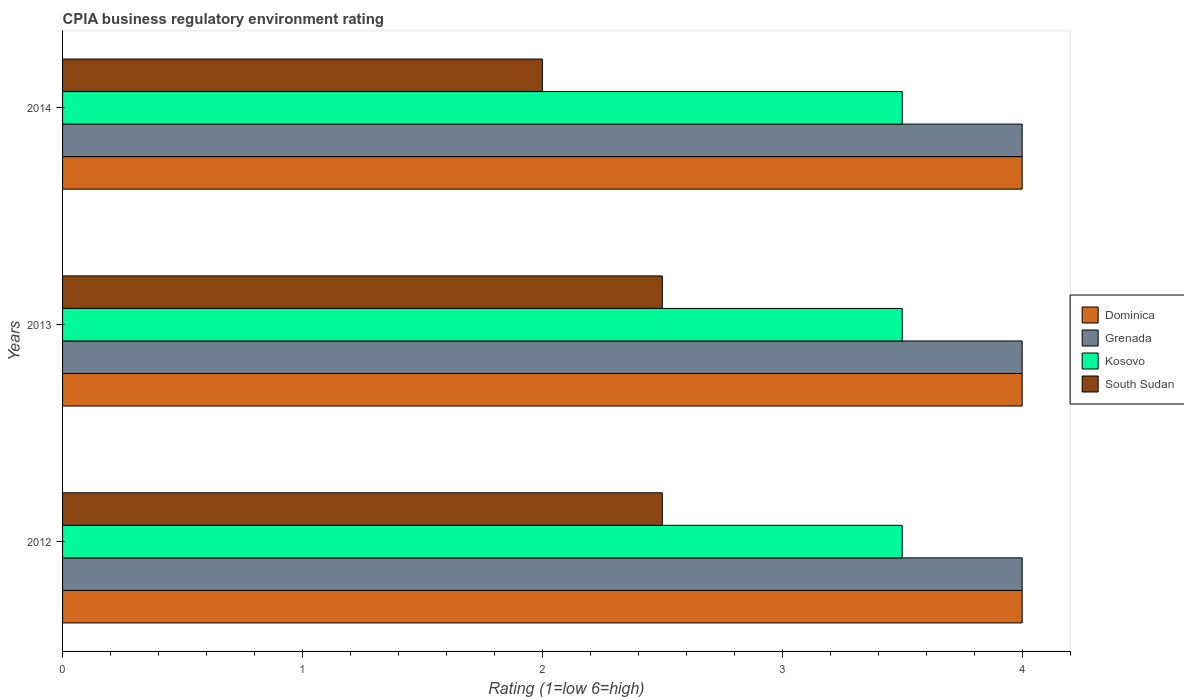How many different coloured bars are there?
Keep it short and to the point. 4. How many groups of bars are there?
Keep it short and to the point. 3. Are the number of bars on each tick of the Y-axis equal?
Ensure brevity in your answer.  Yes. How many bars are there on the 1st tick from the top?
Keep it short and to the point. 4. How many bars are there on the 1st tick from the bottom?
Make the answer very short. 4. What is the CPIA rating in Dominica in 2012?
Provide a succinct answer. 4. Across all years, what is the minimum CPIA rating in South Sudan?
Provide a succinct answer. 2. In which year was the CPIA rating in South Sudan maximum?
Offer a very short reply. 2012. What is the average CPIA rating in South Sudan per year?
Your answer should be very brief. 2.33. In the year 2012, what is the difference between the CPIA rating in Kosovo and CPIA rating in Dominica?
Your answer should be compact. -0.5. In how many years, is the CPIA rating in Kosovo greater than 3.4 ?
Keep it short and to the point. 3. What is the ratio of the CPIA rating in Kosovo in 2012 to that in 2013?
Your response must be concise. 1. Is the CPIA rating in Dominica in 2013 less than that in 2014?
Make the answer very short. No. Is the difference between the CPIA rating in Kosovo in 2012 and 2013 greater than the difference between the CPIA rating in Dominica in 2012 and 2013?
Your answer should be compact. No. What is the difference between the highest and the lowest CPIA rating in South Sudan?
Your response must be concise. 0.5. Is it the case that in every year, the sum of the CPIA rating in Grenada and CPIA rating in South Sudan is greater than the sum of CPIA rating in Kosovo and CPIA rating in Dominica?
Your answer should be compact. No. What does the 2nd bar from the top in 2014 represents?
Offer a terse response. Kosovo. What does the 2nd bar from the bottom in 2012 represents?
Keep it short and to the point. Grenada. Is it the case that in every year, the sum of the CPIA rating in Dominica and CPIA rating in Kosovo is greater than the CPIA rating in Grenada?
Offer a very short reply. Yes. How many bars are there?
Keep it short and to the point. 12. How many years are there in the graph?
Keep it short and to the point. 3. Are the values on the major ticks of X-axis written in scientific E-notation?
Your response must be concise. No. Does the graph contain grids?
Offer a terse response. No. How many legend labels are there?
Your answer should be compact. 4. What is the title of the graph?
Ensure brevity in your answer.  CPIA business regulatory environment rating. Does "Nicaragua" appear as one of the legend labels in the graph?
Offer a terse response. No. What is the label or title of the X-axis?
Your answer should be very brief. Rating (1=low 6=high). What is the Rating (1=low 6=high) in Kosovo in 2013?
Ensure brevity in your answer.  3.5. What is the Rating (1=low 6=high) of South Sudan in 2013?
Ensure brevity in your answer.  2.5. What is the Rating (1=low 6=high) in Dominica in 2014?
Offer a very short reply. 4. What is the Rating (1=low 6=high) in Grenada in 2014?
Your answer should be compact. 4. Across all years, what is the maximum Rating (1=low 6=high) in Dominica?
Provide a succinct answer. 4. Across all years, what is the maximum Rating (1=low 6=high) in Grenada?
Offer a terse response. 4. Across all years, what is the maximum Rating (1=low 6=high) of South Sudan?
Your response must be concise. 2.5. Across all years, what is the minimum Rating (1=low 6=high) of South Sudan?
Give a very brief answer. 2. What is the total Rating (1=low 6=high) of Dominica in the graph?
Your answer should be very brief. 12. What is the total Rating (1=low 6=high) in Grenada in the graph?
Offer a very short reply. 12. What is the difference between the Rating (1=low 6=high) of Dominica in 2012 and that in 2014?
Your answer should be very brief. 0. What is the difference between the Rating (1=low 6=high) of Grenada in 2012 and that in 2014?
Your answer should be compact. 0. What is the difference between the Rating (1=low 6=high) in Kosovo in 2012 and that in 2014?
Ensure brevity in your answer.  0. What is the difference between the Rating (1=low 6=high) in South Sudan in 2012 and that in 2014?
Provide a short and direct response. 0.5. What is the difference between the Rating (1=low 6=high) of Kosovo in 2013 and that in 2014?
Offer a very short reply. 0. What is the difference between the Rating (1=low 6=high) of Dominica in 2012 and the Rating (1=low 6=high) of South Sudan in 2013?
Provide a short and direct response. 1.5. What is the difference between the Rating (1=low 6=high) in Grenada in 2012 and the Rating (1=low 6=high) in Kosovo in 2013?
Your answer should be very brief. 0.5. What is the difference between the Rating (1=low 6=high) in Grenada in 2012 and the Rating (1=low 6=high) in South Sudan in 2013?
Ensure brevity in your answer.  1.5. What is the difference between the Rating (1=low 6=high) of Dominica in 2012 and the Rating (1=low 6=high) of South Sudan in 2014?
Keep it short and to the point. 2. What is the difference between the Rating (1=low 6=high) in Grenada in 2012 and the Rating (1=low 6=high) in Kosovo in 2014?
Offer a terse response. 0.5. What is the difference between the Rating (1=low 6=high) in Grenada in 2012 and the Rating (1=low 6=high) in South Sudan in 2014?
Offer a terse response. 2. What is the difference between the Rating (1=low 6=high) of Grenada in 2013 and the Rating (1=low 6=high) of Kosovo in 2014?
Provide a short and direct response. 0.5. What is the average Rating (1=low 6=high) of Grenada per year?
Provide a short and direct response. 4. What is the average Rating (1=low 6=high) of Kosovo per year?
Your answer should be compact. 3.5. What is the average Rating (1=low 6=high) in South Sudan per year?
Provide a succinct answer. 2.33. In the year 2012, what is the difference between the Rating (1=low 6=high) of Kosovo and Rating (1=low 6=high) of South Sudan?
Your answer should be very brief. 1. In the year 2013, what is the difference between the Rating (1=low 6=high) of Dominica and Rating (1=low 6=high) of Grenada?
Your response must be concise. 0. In the year 2013, what is the difference between the Rating (1=low 6=high) of Dominica and Rating (1=low 6=high) of Kosovo?
Provide a short and direct response. 0.5. In the year 2013, what is the difference between the Rating (1=low 6=high) of Dominica and Rating (1=low 6=high) of South Sudan?
Offer a very short reply. 1.5. In the year 2013, what is the difference between the Rating (1=low 6=high) in Grenada and Rating (1=low 6=high) in Kosovo?
Your answer should be compact. 0.5. In the year 2013, what is the difference between the Rating (1=low 6=high) in Grenada and Rating (1=low 6=high) in South Sudan?
Your answer should be compact. 1.5. In the year 2014, what is the difference between the Rating (1=low 6=high) in Dominica and Rating (1=low 6=high) in Grenada?
Give a very brief answer. 0. In the year 2014, what is the difference between the Rating (1=low 6=high) in Dominica and Rating (1=low 6=high) in Kosovo?
Provide a short and direct response. 0.5. In the year 2014, what is the difference between the Rating (1=low 6=high) in Dominica and Rating (1=low 6=high) in South Sudan?
Give a very brief answer. 2. In the year 2014, what is the difference between the Rating (1=low 6=high) in Grenada and Rating (1=low 6=high) in South Sudan?
Your answer should be very brief. 2. What is the ratio of the Rating (1=low 6=high) of Dominica in 2012 to that in 2013?
Your answer should be compact. 1. What is the ratio of the Rating (1=low 6=high) of Grenada in 2012 to that in 2013?
Your answer should be compact. 1. What is the ratio of the Rating (1=low 6=high) in Kosovo in 2012 to that in 2013?
Give a very brief answer. 1. What is the ratio of the Rating (1=low 6=high) of Kosovo in 2012 to that in 2014?
Keep it short and to the point. 1. What is the ratio of the Rating (1=low 6=high) of Dominica in 2013 to that in 2014?
Provide a succinct answer. 1. What is the ratio of the Rating (1=low 6=high) in South Sudan in 2013 to that in 2014?
Offer a terse response. 1.25. What is the difference between the highest and the second highest Rating (1=low 6=high) in Dominica?
Ensure brevity in your answer.  0. What is the difference between the highest and the second highest Rating (1=low 6=high) in Grenada?
Ensure brevity in your answer.  0. What is the difference between the highest and the second highest Rating (1=low 6=high) in Kosovo?
Your answer should be compact. 0. What is the difference between the highest and the second highest Rating (1=low 6=high) in South Sudan?
Provide a short and direct response. 0. What is the difference between the highest and the lowest Rating (1=low 6=high) of South Sudan?
Your answer should be compact. 0.5. 